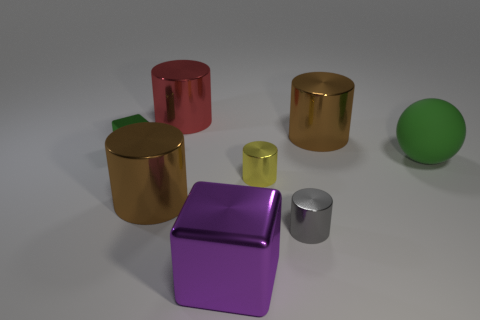There is a large metallic cylinder right of the tiny gray thing; what color is it?
Offer a very short reply. Brown. Are there any large metallic cylinders that have the same color as the sphere?
Provide a succinct answer. No. The shiny block that is the same size as the red cylinder is what color?
Offer a terse response. Purple. Is the tiny yellow object the same shape as the purple shiny object?
Offer a terse response. No. What is the material of the cube in front of the gray shiny object?
Your answer should be compact. Metal. What is the color of the big shiny block?
Your response must be concise. Purple. There is a brown metallic cylinder that is in front of the green matte ball; is it the same size as the green cube that is on the left side of the matte object?
Keep it short and to the point. No. How big is the shiny thing that is to the right of the yellow metal cylinder and behind the sphere?
Keep it short and to the point. Large. What is the color of the other tiny metallic thing that is the same shape as the yellow shiny thing?
Offer a very short reply. Gray. Are there more purple things that are to the left of the small green object than tiny shiny objects behind the green ball?
Offer a terse response. No. 